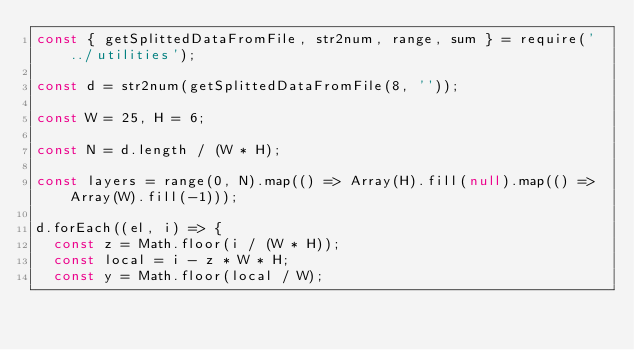<code> <loc_0><loc_0><loc_500><loc_500><_JavaScript_>const { getSplittedDataFromFile, str2num, range, sum } = require('../utilities');

const d = str2num(getSplittedDataFromFile(8, ''));

const W = 25, H = 6;

const N = d.length / (W * H);

const layers = range(0, N).map(() => Array(H).fill(null).map(() => Array(W).fill(-1)));

d.forEach((el, i) => {
  const z = Math.floor(i / (W * H));
  const local = i - z * W * H;
  const y = Math.floor(local / W);</code> 